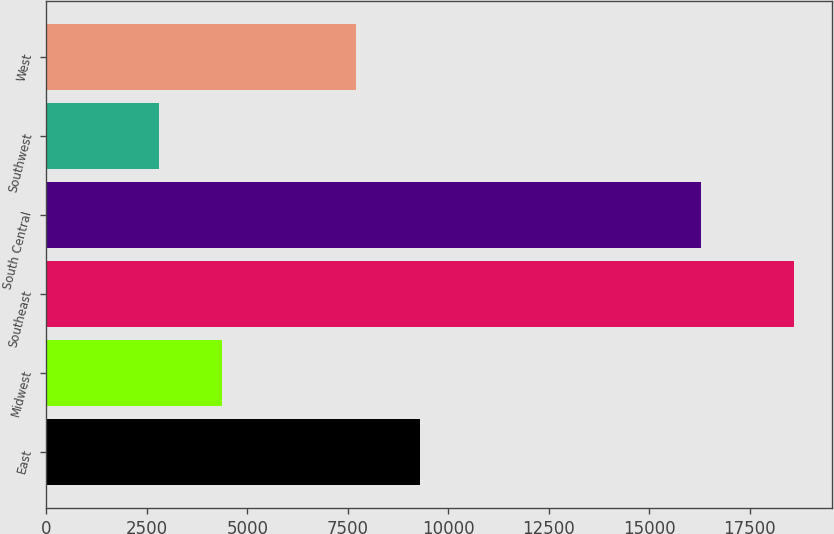Convert chart. <chart><loc_0><loc_0><loc_500><loc_500><bar_chart><fcel>East<fcel>Midwest<fcel>Southeast<fcel>South Central<fcel>Southwest<fcel>West<nl><fcel>9297.2<fcel>4378.2<fcel>18609<fcel>16278<fcel>2797<fcel>7716<nl></chart> 